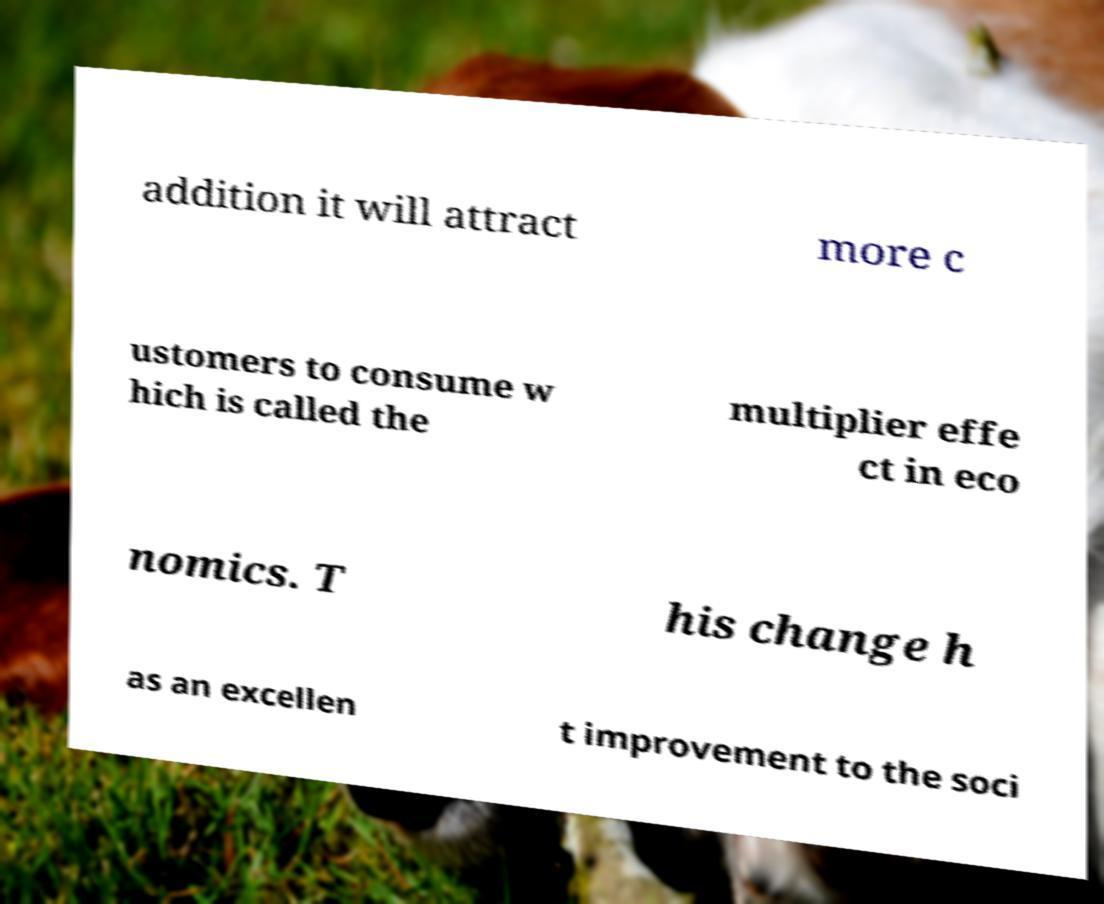Can you accurately transcribe the text from the provided image for me? addition it will attract more c ustomers to consume w hich is called the multiplier effe ct in eco nomics. T his change h as an excellen t improvement to the soci 